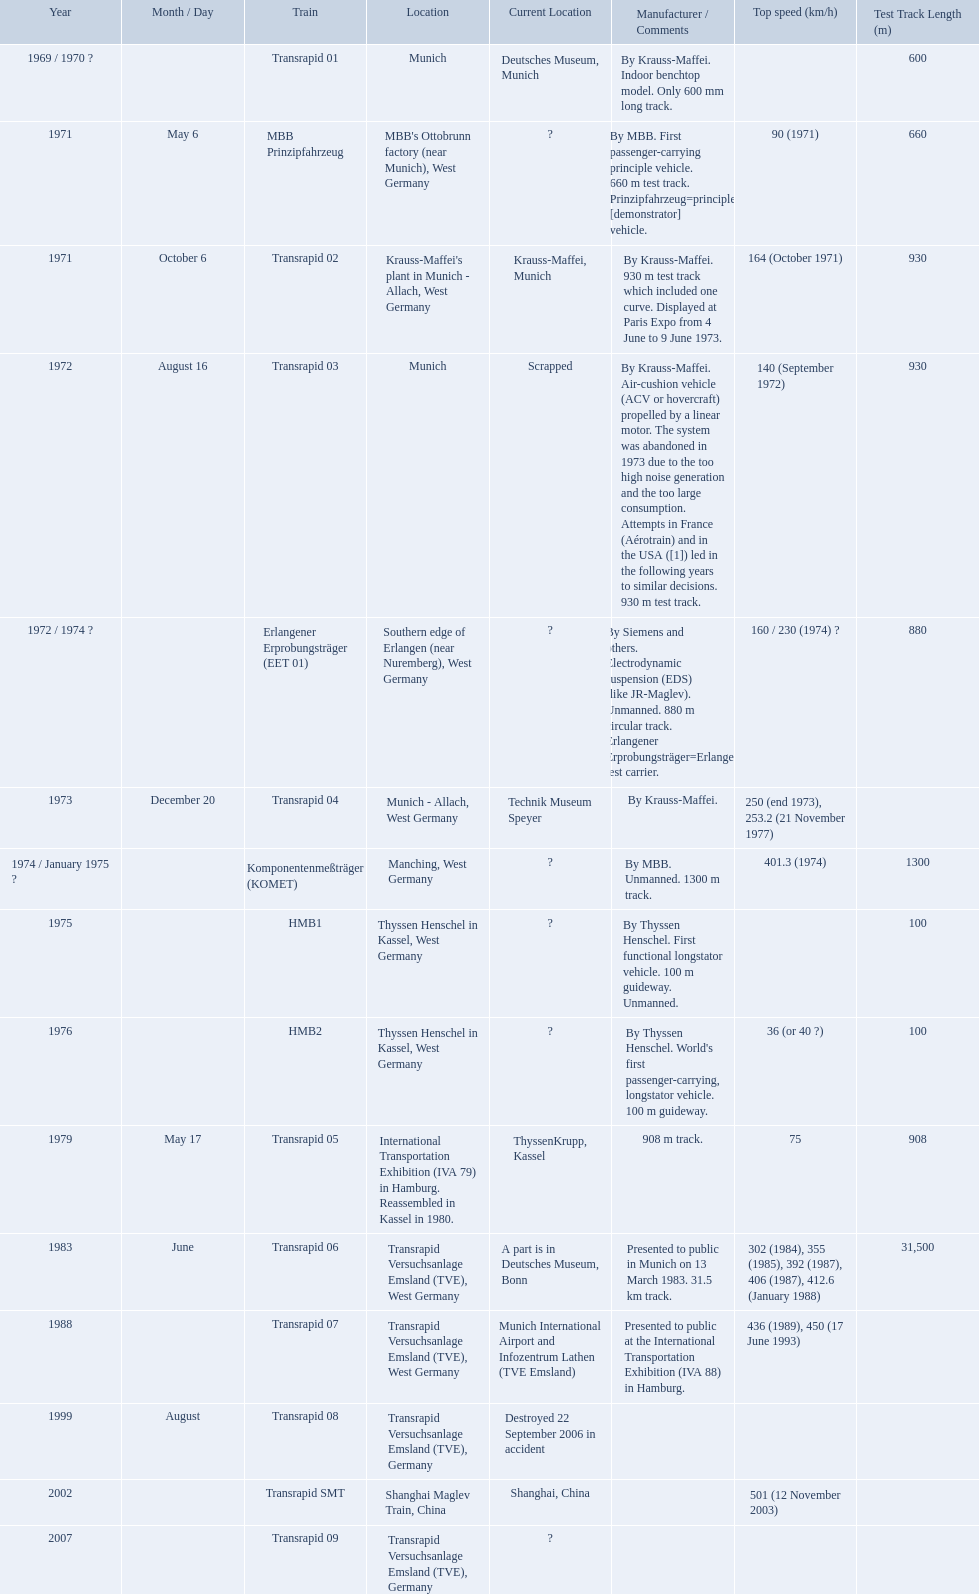What are the names of each transrapid train? Transrapid 01, MBB Prinzipfahrzeug, Transrapid 02, Transrapid 03, Erlangener Erprobungsträger (EET 01), Transrapid 04, Komponentenmeßträger (KOMET), HMB1, HMB2, Transrapid 05, Transrapid 06, Transrapid 07, Transrapid 08, Transrapid SMT, Transrapid 09. What are their listed top speeds? 90 (1971), 164 (October 1971), 140 (September 1972), 160 / 230 (1974) ?, 250 (end 1973), 253.2 (21 November 1977), 401.3 (1974), 36 (or 40 ?), 75, 302 (1984), 355 (1985), 392 (1987), 406 (1987), 412.6 (January 1988), 436 (1989), 450 (17 June 1993), 501 (12 November 2003). And which train operates at the fastest speed? Transrapid SMT. Which trains exceeded a top speed of 400+? Komponentenmeßträger (KOMET), Transrapid 07, Transrapid SMT. How about 500+? Transrapid SMT. 